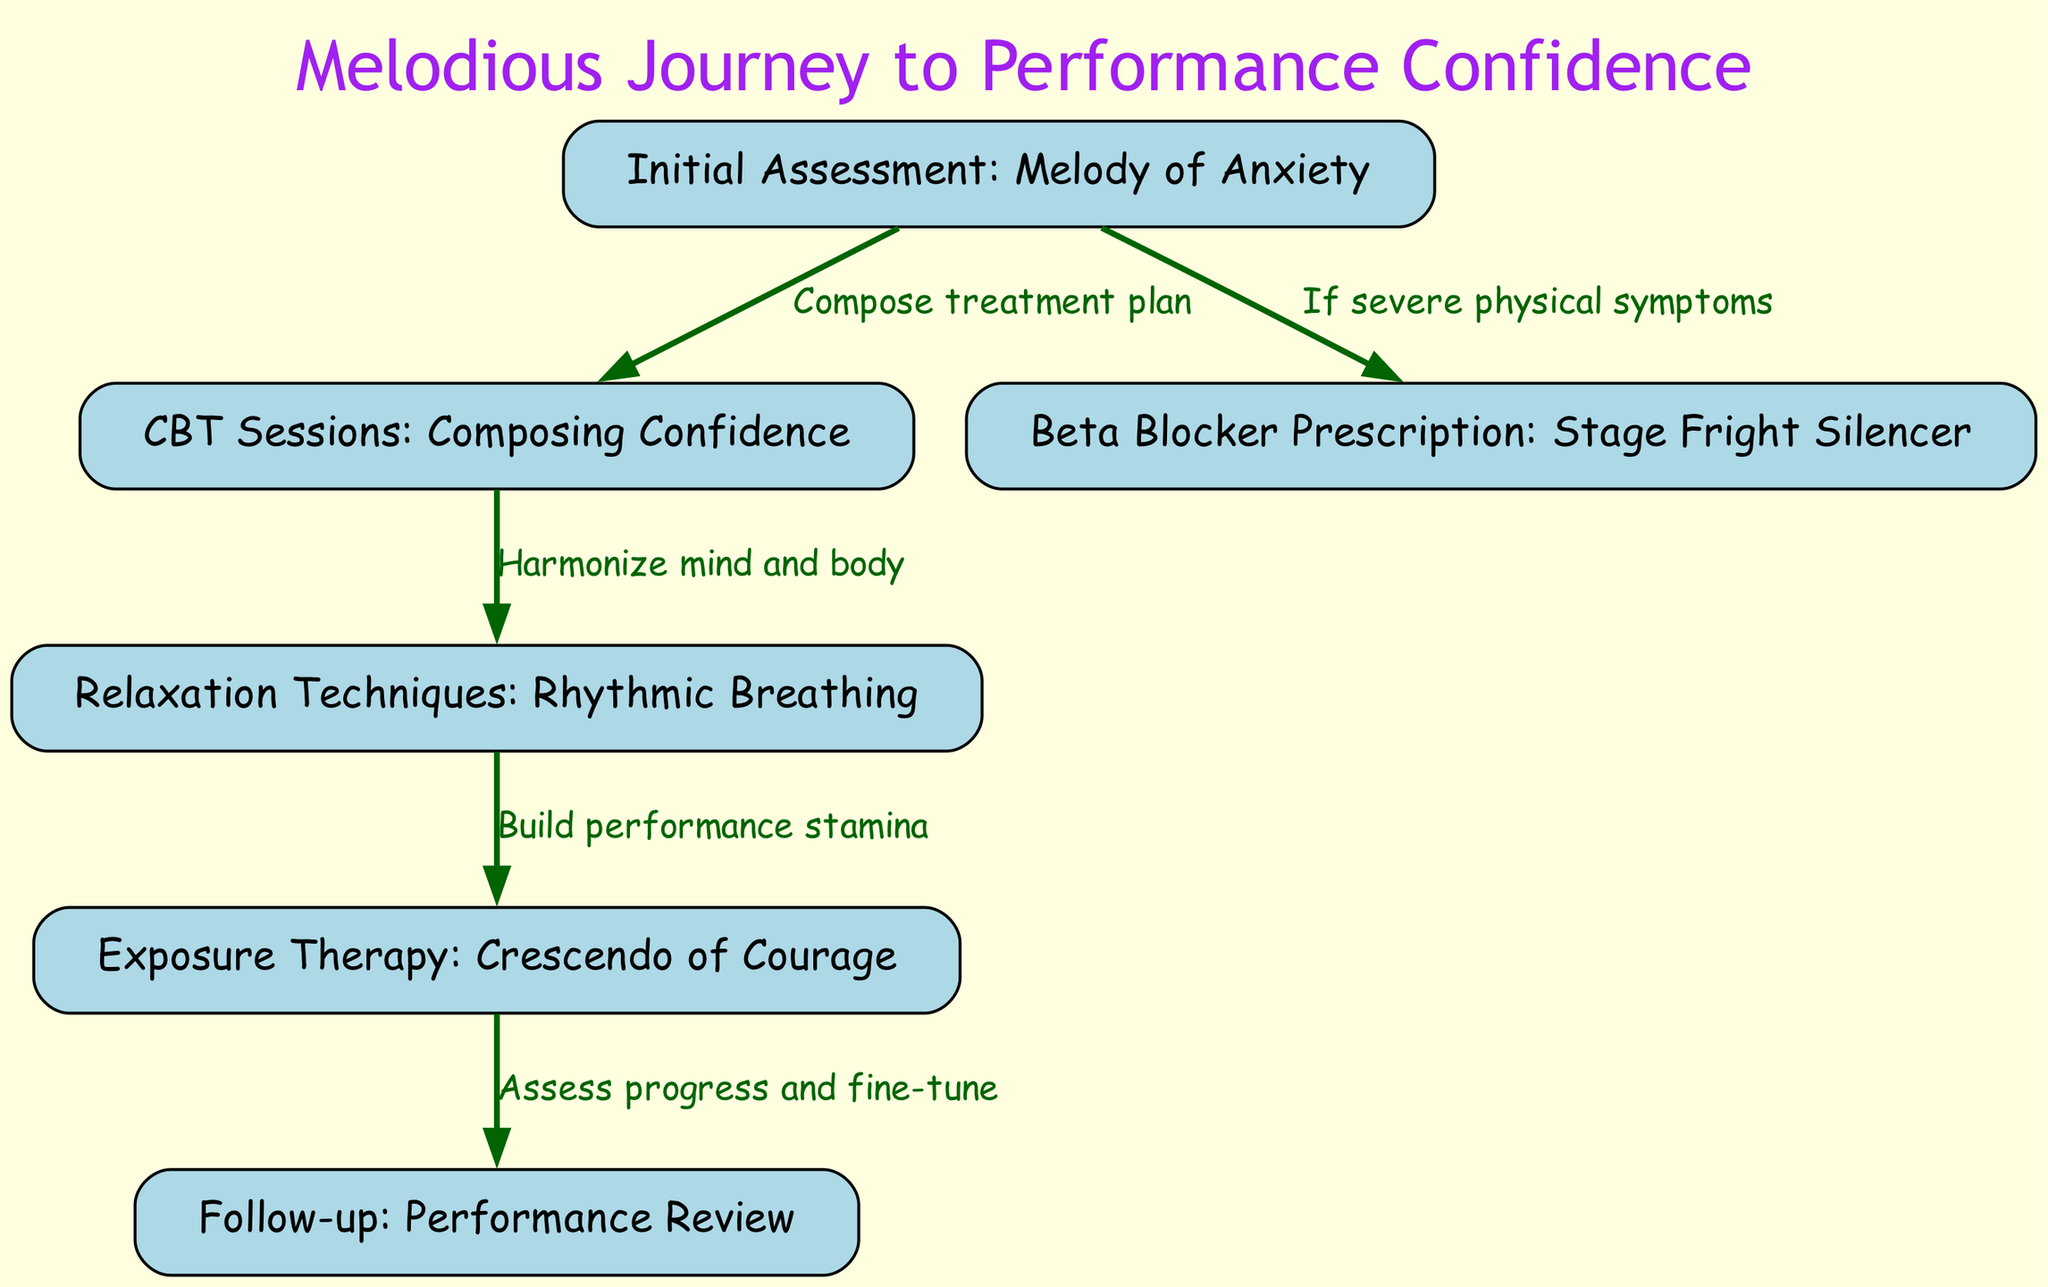What is the first step in the treatment plan? The diagram indicates that the first step is the "Initial Assessment: Melody of Anxiety," which leads to identifying the treatment path for performance anxiety.
Answer: Initial Assessment: Melody of Anxiety How many nodes are present in the diagram? By counting the nodes listed, there are a total of six distinct nodes that represent different stages or components of the clinical pathway.
Answer: 6 What happens after CBT Sessions? According to the diagram, the next step after "CBT Sessions: Composing Confidence" is "Relaxation Techniques: Rhythmic Breathing," indicating a follow-up step in the treatment process.
Answer: Relaxation Techniques: Rhythmic Breathing What occurs if physical symptoms are severe? The diagram specifies that if severe physical symptoms are present, a "Beta Blocker Prescription: Stage Fright Silencer" will be issued as part of the treatment plan.
Answer: Beta Blocker Prescription: Stage Fright Silencer Which technique is used to build performance stamina? The diagram shows that "Exposure Therapy: Crescendo of Courage" is the technique employed after relaxation techniques to enhance performance stamina.
Answer: Exposure Therapy: Crescendo of Courage Explain the relationship between relaxation techniques and exposure therapy. The diagram reveals an arrow connecting "Relaxation Techniques: Rhythmic Breathing" to "Exposure Therapy: Crescendo of Courage," indicating that mastering relaxation techniques is essential before undertaking exposure therapy for performance anxiety.
Answer: Build performance stamina What is the final step in the clinical pathway? The last node in the pathway, as depicted in the diagram, is "Follow-up: Performance Review," which functions as an evaluation of the treatment’s effectiveness and progress made.
Answer: Follow-up: Performance Review 